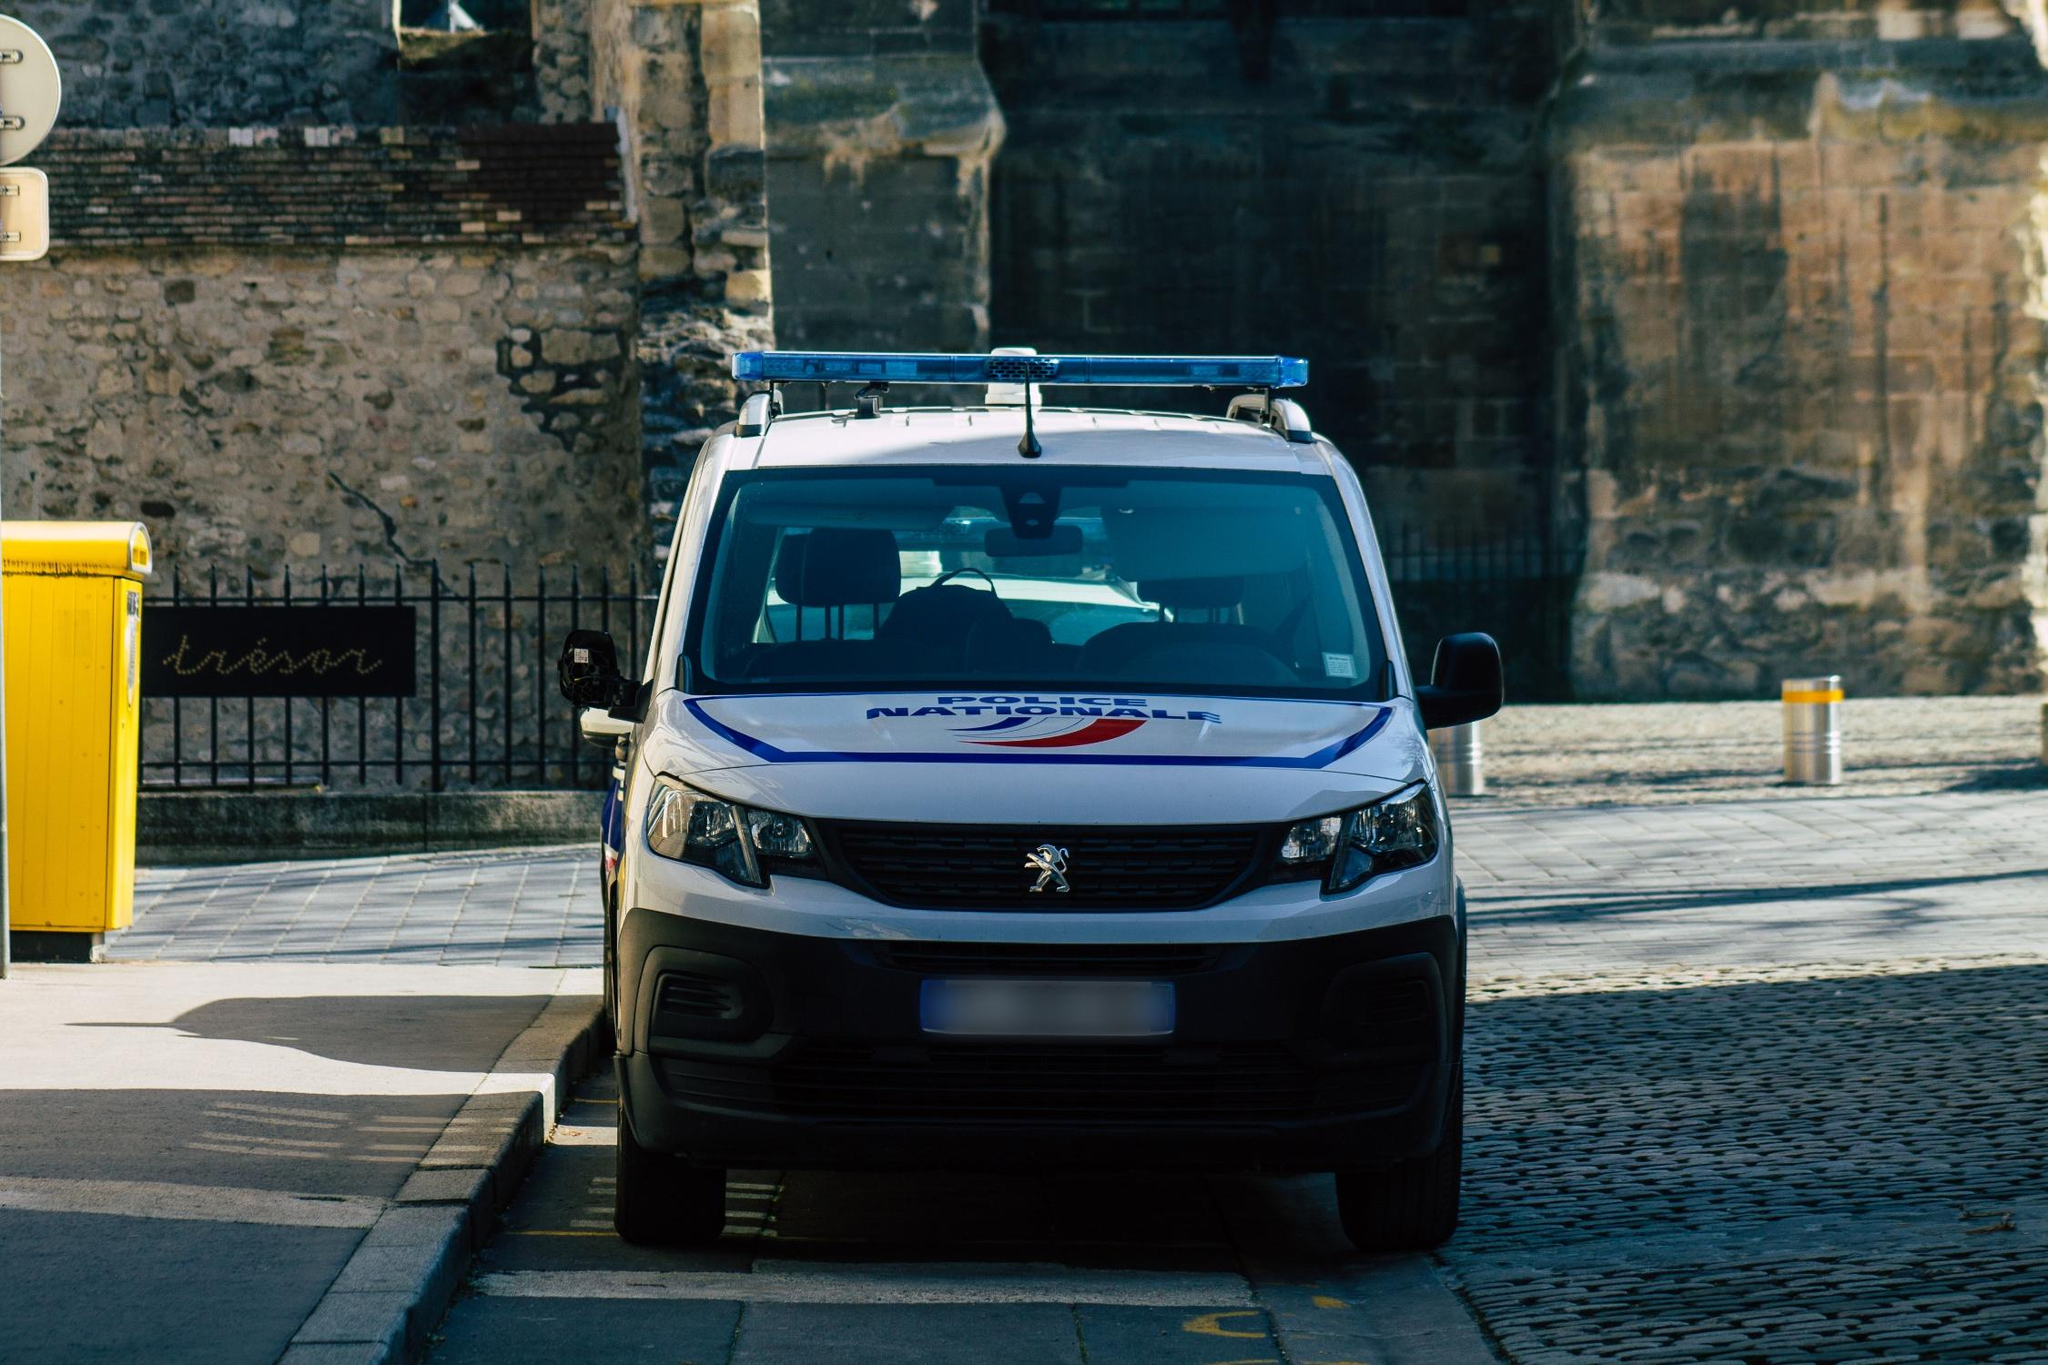Can you elaborate on the elements of the picture provided? The image presents a close view of a white Peugeot van parked on a cobblestone street, possibly in a European city given the architectural style of the stone wall behind it. The van features a distinctive blue and red logo that reads 'Nationale Politie', indicating it's a vehicle used by the Dutch National Police. Additional elements such as the blue police beacon on top and its position on the street suggest readiness for quick deployment.

The backdrop includes a historic-looking stone wall with a decorative metal sign that appears to spell 'jjear' or 'year', adding a touch of artistry to the scene. Furthermore, the setting includes modern city elements such as yellow bollards and a matching yellow trash can which make for a contrasting color scenery. Overall, this detailed depiction alludes to a blend between historical character and contemporary urban life. 